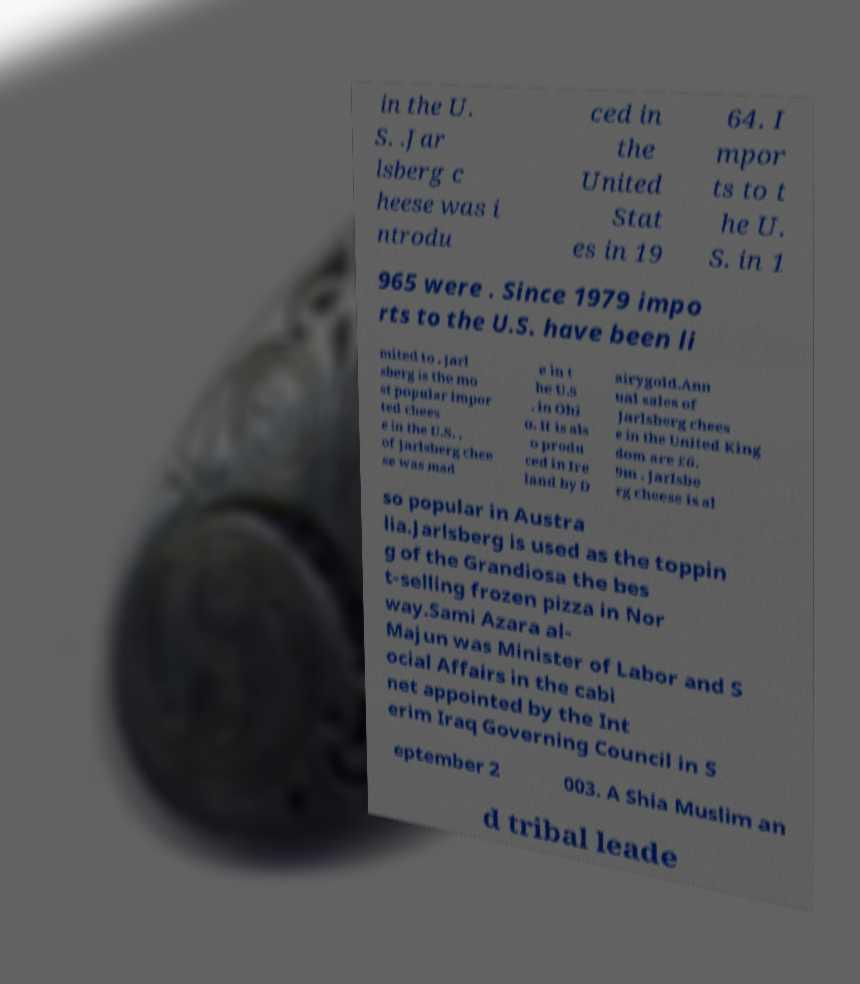There's text embedded in this image that I need extracted. Can you transcribe it verbatim? in the U. S. .Jar lsberg c heese was i ntrodu ced in the United Stat es in 19 64. I mpor ts to t he U. S. in 1 965 were . Since 1979 impo rts to the U.S. have been li mited to . Jarl sberg is the mo st popular impor ted chees e in the U.S. , of Jarlsberg chee se was mad e in t he U.S . in Ohi o. It is als o produ ced in Ire land by D airygold.Ann ual sales of Jarlsberg chees e in the United King dom are £6. 9m . Jarlsbe rg cheese is al so popular in Austra lia.Jarlsberg is used as the toppin g of the Grandiosa the bes t-selling frozen pizza in Nor way.Sami Azara al- Majun was Minister of Labor and S ocial Affairs in the cabi net appointed by the Int erim Iraq Governing Council in S eptember 2 003. A Shia Muslim an d tribal leade 